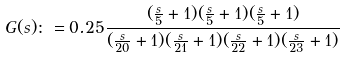Convert formula to latex. <formula><loc_0><loc_0><loc_500><loc_500>G ( s ) \colon = 0 . 2 5 \frac { ( \frac { s } { 5 } + 1 ) ( \frac { s } { 5 } + 1 ) ( \frac { s } { 5 } + 1 ) } { ( \frac { s } { 2 0 } + 1 ) ( \frac { s } { 2 1 } + 1 ) ( \frac { s } { 2 2 } + 1 ) ( \frac { s } { 2 3 } + 1 ) }</formula> 